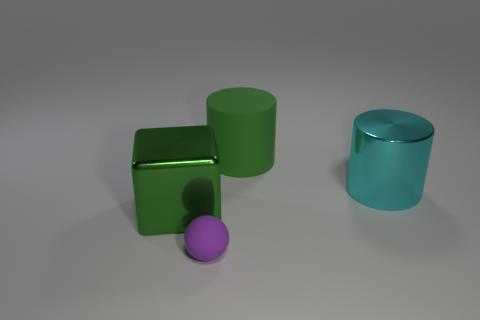Add 2 green objects. How many objects exist? 6 Subtract all cubes. How many objects are left? 3 Add 1 matte cylinders. How many matte cylinders are left? 2 Add 3 green cylinders. How many green cylinders exist? 4 Subtract 0 brown cylinders. How many objects are left? 4 Subtract all big yellow rubber cylinders. Subtract all purple rubber balls. How many objects are left? 3 